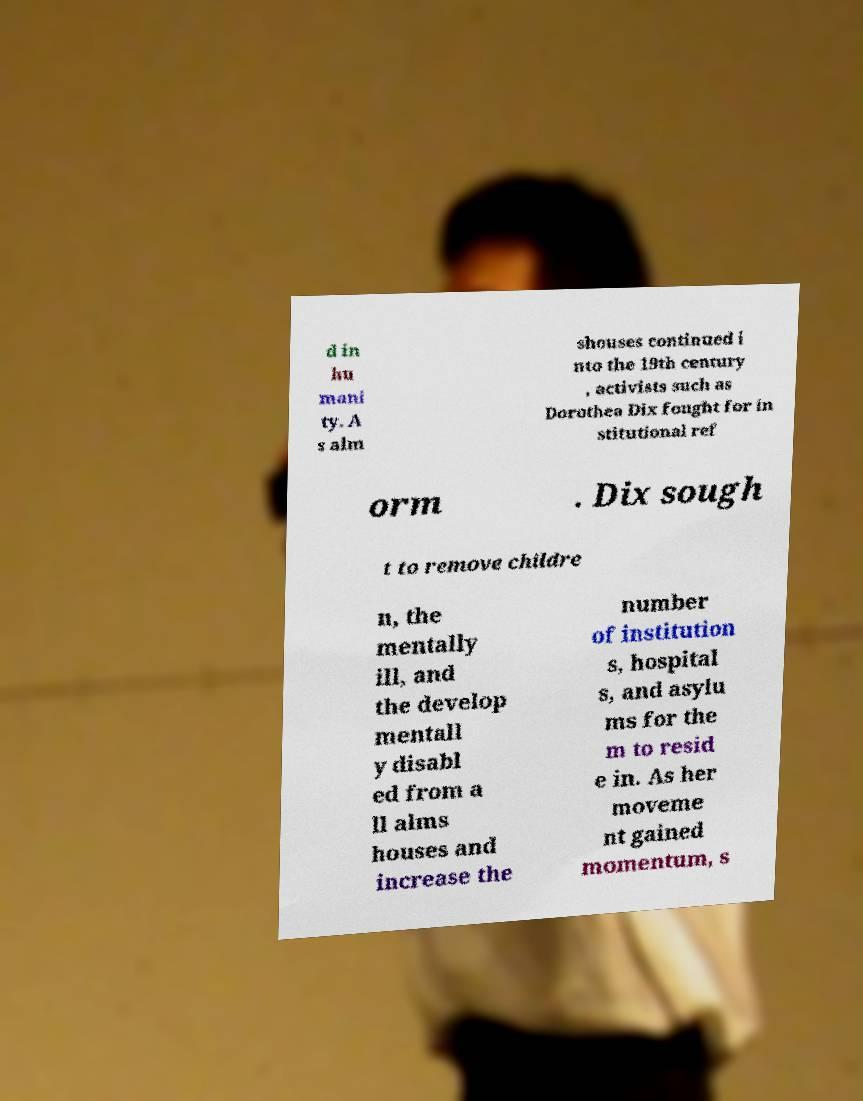Please read and relay the text visible in this image. What does it say? d in hu mani ty. A s alm shouses continued i nto the 19th century , activists such as Dorothea Dix fought for in stitutional ref orm . Dix sough t to remove childre n, the mentally ill, and the develop mentall y disabl ed from a ll alms houses and increase the number of institution s, hospital s, and asylu ms for the m to resid e in. As her moveme nt gained momentum, s 